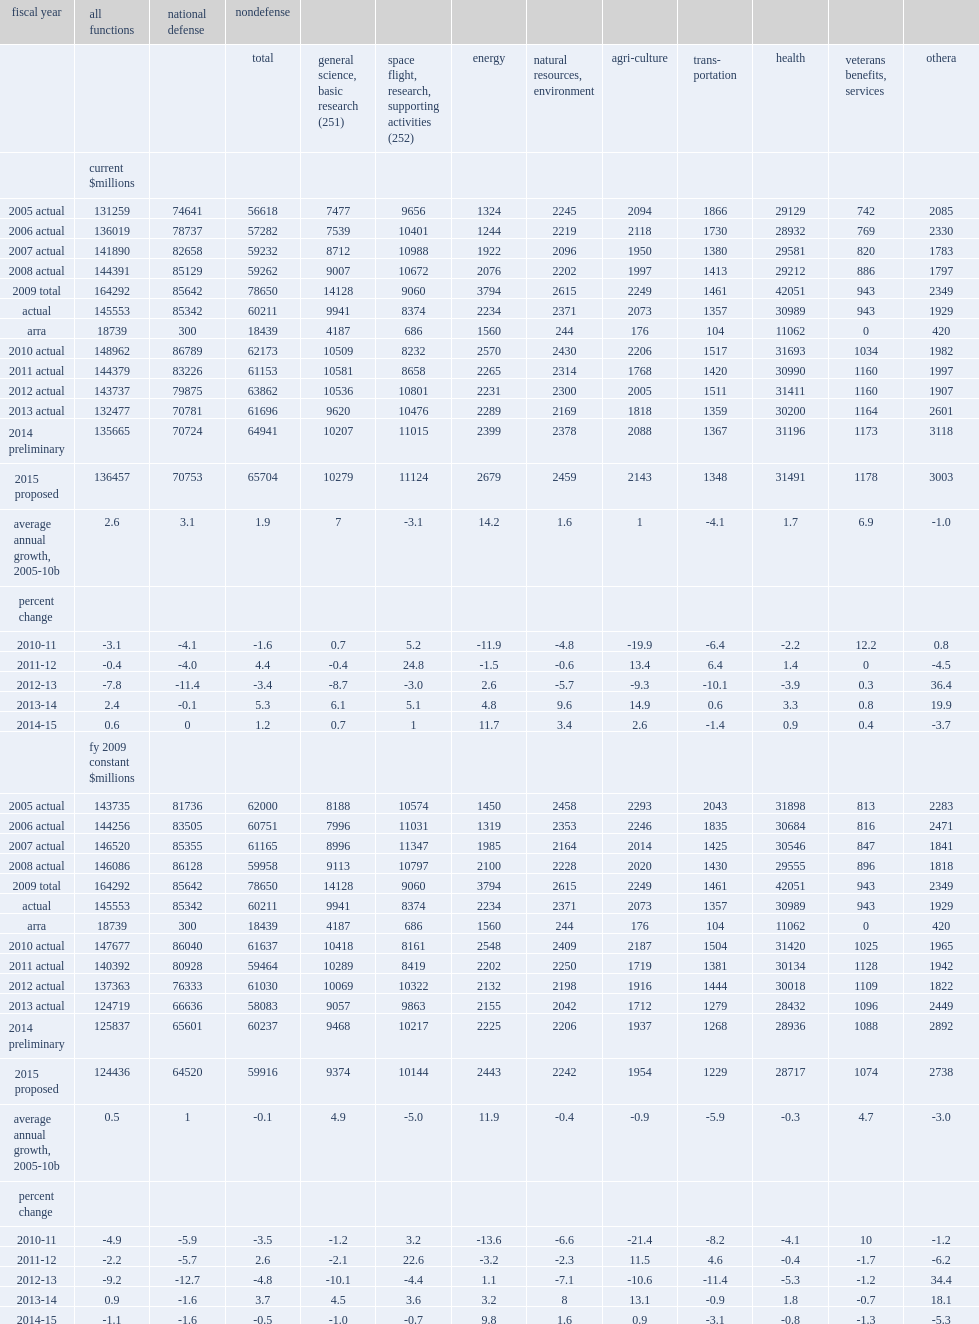How many million dollars did federal budget authority for research and development and r&d plant together total in fy 2014? 135665.0. Federal budget authority for research and development and r&d plant together totaled an estimated $135.7 million in fy 2014, what was an increase of million dollars over the fy 2013 level? 3188. Federal budget authority for research and development and r&d plant together totaled an estimated $135.7 billion in fy 2014, what was the percent of increase over the fy 2013 level? 2.4. How many million dollars did budget authority for r&d and r&d plant drop in fy 2011? -4583. How many million dollars did budget authority for r&d and r&d plant drop down to a total? 144379.0. How many million dollars did budget authority for r&d and r&d plant drop in fy 2012? -642. How many million dollars did budget authority for r&d and r&d plant drop down to a total? 143737.0. How many million dollars did budget authority for r&d and r&d plant drop in fy 2013? -11260. How many million dollars did budget authority for r&d and r&d plant drop down to a total? 132477.0. How many million dollars did the preliminary fy 2014 level increase by? 3188. How many million dollars did the preliminary fy 2014 level increase up to? 135665.0. 